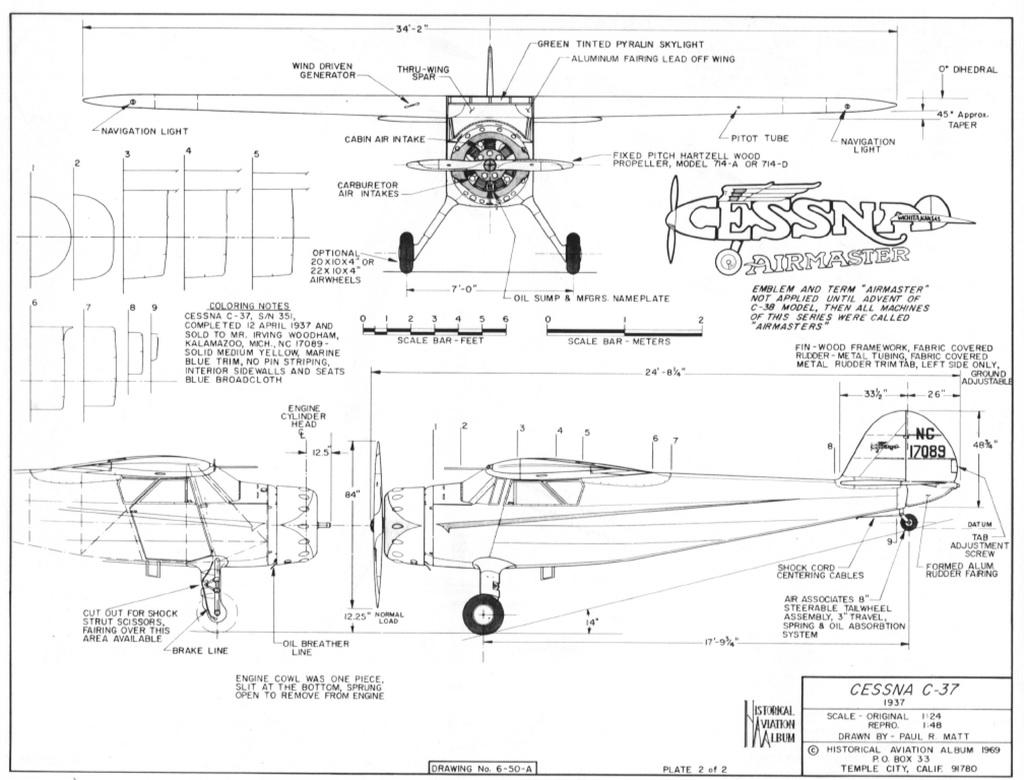What is the main subject of the image? There is a sketch in the image. What type of zephyr is depicted in the sketch? There is no zephyr depicted in the sketch, as a zephyr refers to a gentle breeze, which is not a subject that can be sketched. 